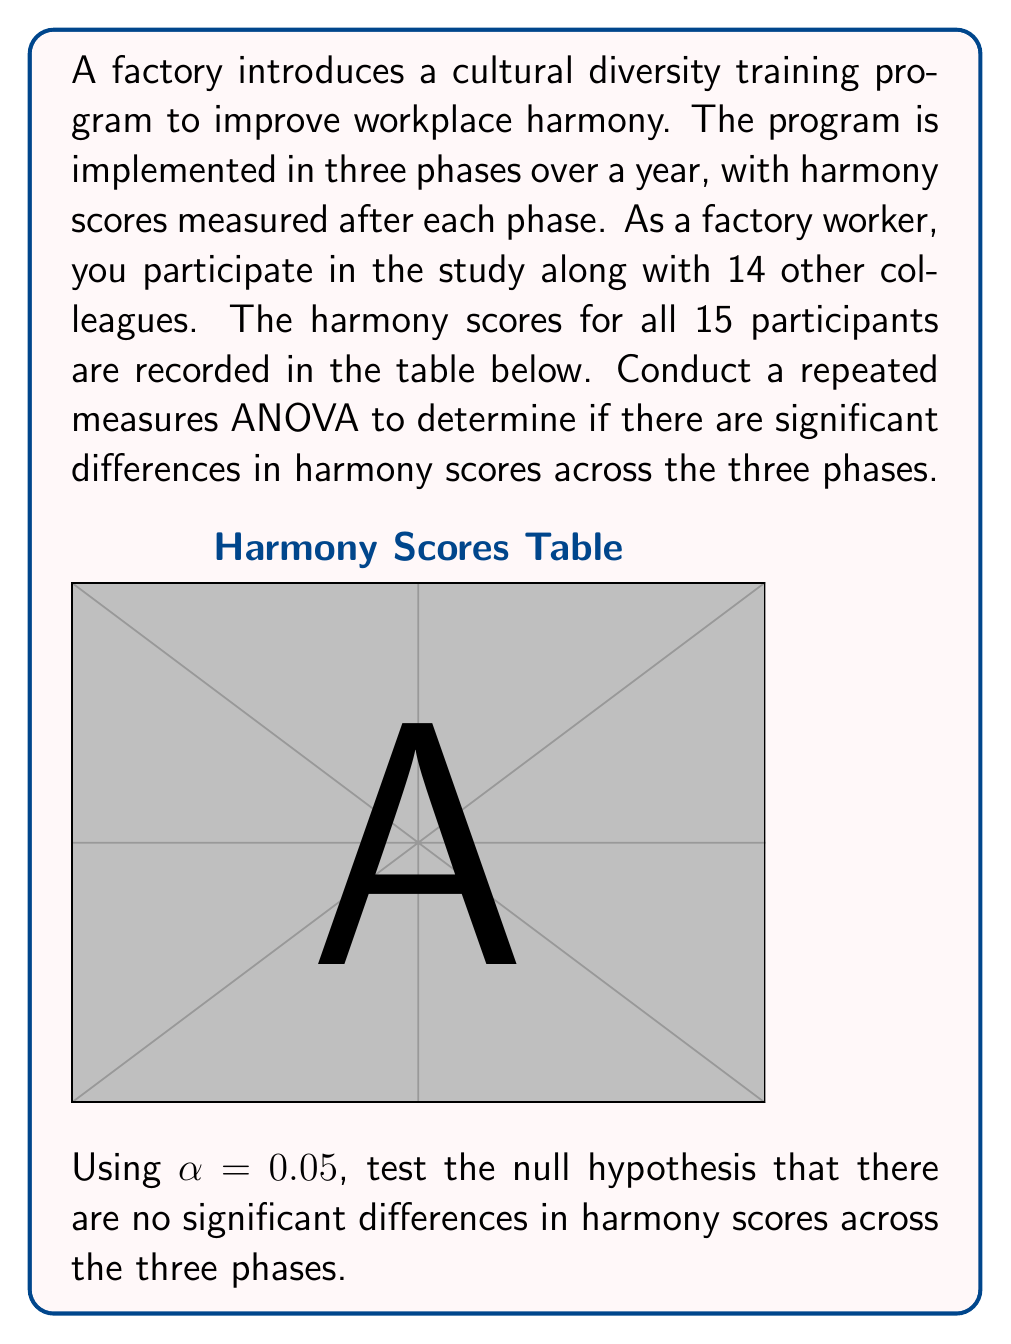Can you solve this math problem? To conduct a repeated measures ANOVA, we'll follow these steps:

1) Calculate the total sum of squares (SST):
   $$SST = \sum X^2 - \frac{(\sum X)^2}{N}$$
   where N is the total number of scores (15 * 3 = 45)
   $$SST = (34800 + 47400 + 58200) - \frac{(720 + 840 + 930)^2}{45}$$
   $$SST = 140400 - \frac{2490000}{45} = 140400 - 55333.33 = 85066.67$$

2) Calculate the sum of squares between treatments (SSB):
   $$SSB = \frac{\sum(\sum X_i)^2}{n} - \frac{(\sum X)^2}{N}$$
   where n is the number of participants (15)
   $$SSB = \frac{720^2 + 840^2 + 930^2}{15} - \frac{2490000}{45}$$
   $$SSB = 57800 - 55333.33 = 2466.67$$

3) Calculate the sum of squares within treatments (SSW):
   $$SSW = SST - SSB = 85066.67 - 2466.67 = 82600$$

4) Calculate degrees of freedom:
   df between = k - 1 = 3 - 1 = 2 (k is the number of treatments)
   df within = N - k = 45 - 3 = 42
   df total = N - 1 = 45 - 1 = 44

5) Calculate mean squares:
   $$MSB = \frac{SSB}{df_{between}} = \frac{2466.67}{2} = 1233.34$$
   $$MSW = \frac{SSW}{df_{within}} = \frac{82600}{42} = 1966.67$$

6) Calculate F-ratio:
   $$F = \frac{MSB}{MSW} = \frac{1233.34}{1966.67} = 0.627$$

7) Find the critical F-value:
   For $\alpha = 0.05$, df between = 2, df within = 42
   F-critical = 3.22 (from F-distribution table)

8) Compare F-ratio to F-critical:
   Since 0.627 < 3.22, we fail to reject the null hypothesis.
Answer: F(2,42) = 0.627, p > 0.05. No significant differences in harmony scores across phases. 